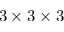Convert formula to latex. <formula><loc_0><loc_0><loc_500><loc_500>3 \times 3 \times 3</formula> 